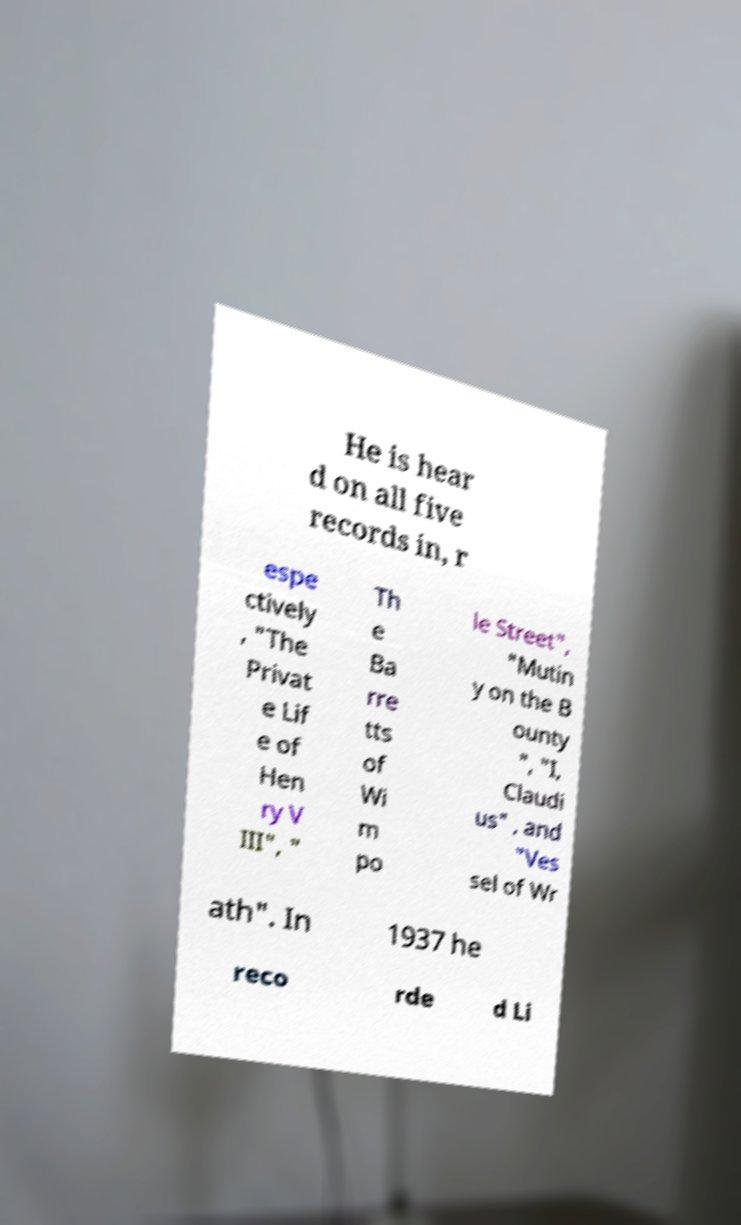What messages or text are displayed in this image? I need them in a readable, typed format. He is hear d on all five records in, r espe ctively , "The Privat e Lif e of Hen ry V III", " Th e Ba rre tts of Wi m po le Street", "Mutin y on the B ounty ", "I, Claudi us" , and "Ves sel of Wr ath". In 1937 he reco rde d Li 